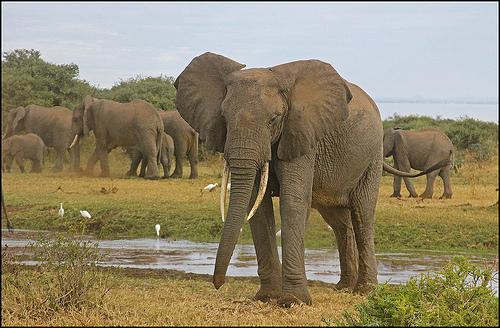Explain the appearance and position of the closest elephant in the image. The closest elephant has large ears, brown tusks, and two white tusks, appearing to be standing in the grass by the water's edge. Describe the overall mood of the image and the surrounding environment. The mood of the image is calm and serene, with a backdrop of a light blue sky, and a herd of magnificent elephants walking in a grassy field. Give a brief description of a prominent aspect of the environment in the image. There is a small body of water with muddy brown water, surrounded by grassy areas with sparse green shrubs and clusters of green bushes. Based on the image provided, identify the primary animal and its distinguishing features. The primary animal is an elephant, which has large floppy ears, long brown tusks, caked-on dirt on its body, and two white tusks. Recount the main subjects positioned near or across the stream in the image. The main subjects near the stream are the closest elephant, a group of elephants on the other side, and the white birds across the stream in the grass. Point out the different groups of animals present in the image. There is a group of elephants on the other side of the water, a smaller elephant in front of larger elephants, white birds on the riverbank, and a white egret-looking bird on the shore. What type of birds can be seen near the water, and what are they doing? Small white egret-looking birds are in the grass by the water and on the shore, while one of them appears to be looking out. Mention any baby animals that are part of the herd in the image. There are baby elephants in the herd as well, walking in the grassy field with the other elephants. Mention a few elements of the scenery in the image, including the sky, grass, and water. The sky is light blue with some white clouds, the grass looks brown and dry, and the water in the small creek appears muddy and shallow. 